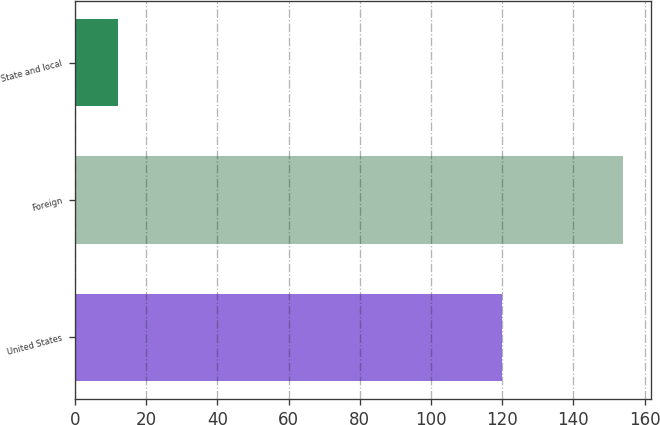Convert chart to OTSL. <chart><loc_0><loc_0><loc_500><loc_500><bar_chart><fcel>United States<fcel>Foreign<fcel>State and local<nl><fcel>120<fcel>154<fcel>12<nl></chart> 